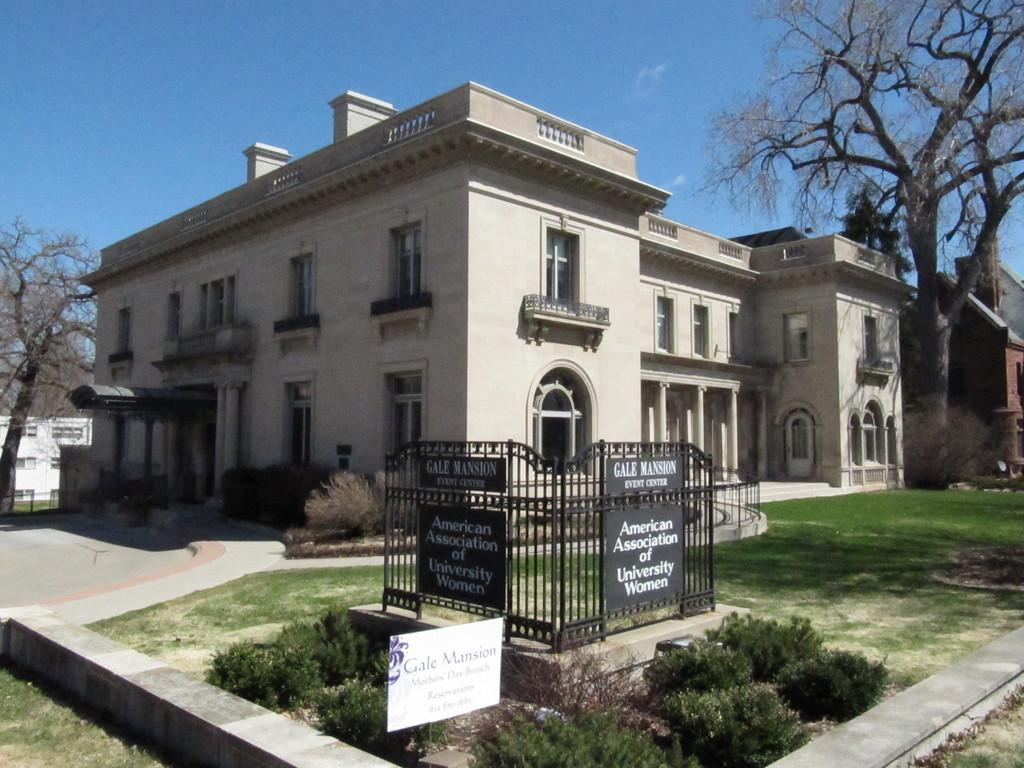What structure is the main subject of the image? There is a building in the image. What can be seen in front of the building? Trees are present in front of the building. What type of terrain is the building situated on? The trees are on a grassland. What is visible above the building? The sky is visible above the building. How many grapes are hanging from the trees in the image? There are no grapes present in the image; the trees are not specified as fruit-bearing trees. 